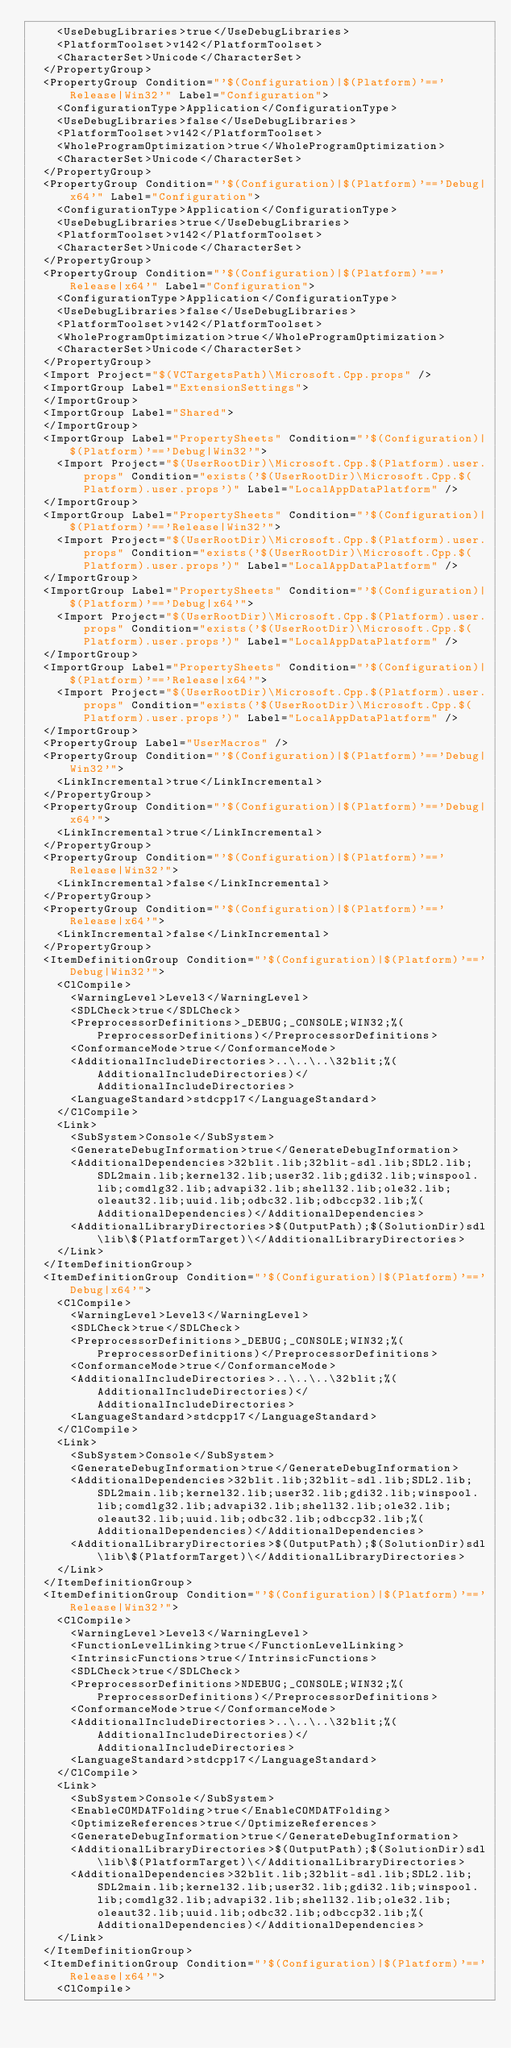<code> <loc_0><loc_0><loc_500><loc_500><_XML_>    <UseDebugLibraries>true</UseDebugLibraries>
    <PlatformToolset>v142</PlatformToolset>
    <CharacterSet>Unicode</CharacterSet>
  </PropertyGroup>
  <PropertyGroup Condition="'$(Configuration)|$(Platform)'=='Release|Win32'" Label="Configuration">
    <ConfigurationType>Application</ConfigurationType>
    <UseDebugLibraries>false</UseDebugLibraries>
    <PlatformToolset>v142</PlatformToolset>
    <WholeProgramOptimization>true</WholeProgramOptimization>
    <CharacterSet>Unicode</CharacterSet>
  </PropertyGroup>
  <PropertyGroup Condition="'$(Configuration)|$(Platform)'=='Debug|x64'" Label="Configuration">
    <ConfigurationType>Application</ConfigurationType>
    <UseDebugLibraries>true</UseDebugLibraries>
    <PlatformToolset>v142</PlatformToolset>
    <CharacterSet>Unicode</CharacterSet>
  </PropertyGroup>
  <PropertyGroup Condition="'$(Configuration)|$(Platform)'=='Release|x64'" Label="Configuration">
    <ConfigurationType>Application</ConfigurationType>
    <UseDebugLibraries>false</UseDebugLibraries>
    <PlatformToolset>v142</PlatformToolset>
    <WholeProgramOptimization>true</WholeProgramOptimization>
    <CharacterSet>Unicode</CharacterSet>
  </PropertyGroup>
  <Import Project="$(VCTargetsPath)\Microsoft.Cpp.props" />
  <ImportGroup Label="ExtensionSettings">
  </ImportGroup>
  <ImportGroup Label="Shared">
  </ImportGroup>
  <ImportGroup Label="PropertySheets" Condition="'$(Configuration)|$(Platform)'=='Debug|Win32'">
    <Import Project="$(UserRootDir)\Microsoft.Cpp.$(Platform).user.props" Condition="exists('$(UserRootDir)\Microsoft.Cpp.$(Platform).user.props')" Label="LocalAppDataPlatform" />
  </ImportGroup>
  <ImportGroup Label="PropertySheets" Condition="'$(Configuration)|$(Platform)'=='Release|Win32'">
    <Import Project="$(UserRootDir)\Microsoft.Cpp.$(Platform).user.props" Condition="exists('$(UserRootDir)\Microsoft.Cpp.$(Platform).user.props')" Label="LocalAppDataPlatform" />
  </ImportGroup>
  <ImportGroup Label="PropertySheets" Condition="'$(Configuration)|$(Platform)'=='Debug|x64'">
    <Import Project="$(UserRootDir)\Microsoft.Cpp.$(Platform).user.props" Condition="exists('$(UserRootDir)\Microsoft.Cpp.$(Platform).user.props')" Label="LocalAppDataPlatform" />
  </ImportGroup>
  <ImportGroup Label="PropertySheets" Condition="'$(Configuration)|$(Platform)'=='Release|x64'">
    <Import Project="$(UserRootDir)\Microsoft.Cpp.$(Platform).user.props" Condition="exists('$(UserRootDir)\Microsoft.Cpp.$(Platform).user.props')" Label="LocalAppDataPlatform" />
  </ImportGroup>
  <PropertyGroup Label="UserMacros" />
  <PropertyGroup Condition="'$(Configuration)|$(Platform)'=='Debug|Win32'">
    <LinkIncremental>true</LinkIncremental>
  </PropertyGroup>
  <PropertyGroup Condition="'$(Configuration)|$(Platform)'=='Debug|x64'">
    <LinkIncremental>true</LinkIncremental>
  </PropertyGroup>
  <PropertyGroup Condition="'$(Configuration)|$(Platform)'=='Release|Win32'">
    <LinkIncremental>false</LinkIncremental>
  </PropertyGroup>
  <PropertyGroup Condition="'$(Configuration)|$(Platform)'=='Release|x64'">
    <LinkIncremental>false</LinkIncremental>
  </PropertyGroup>
  <ItemDefinitionGroup Condition="'$(Configuration)|$(Platform)'=='Debug|Win32'">
    <ClCompile>
      <WarningLevel>Level3</WarningLevel>
      <SDLCheck>true</SDLCheck>
      <PreprocessorDefinitions>_DEBUG;_CONSOLE;WIN32;%(PreprocessorDefinitions)</PreprocessorDefinitions>
      <ConformanceMode>true</ConformanceMode>
      <AdditionalIncludeDirectories>..\..\..\32blit;%(AdditionalIncludeDirectories)</AdditionalIncludeDirectories>
      <LanguageStandard>stdcpp17</LanguageStandard>
    </ClCompile>
    <Link>
      <SubSystem>Console</SubSystem>
      <GenerateDebugInformation>true</GenerateDebugInformation>
      <AdditionalDependencies>32blit.lib;32blit-sdl.lib;SDL2.lib;SDL2main.lib;kernel32.lib;user32.lib;gdi32.lib;winspool.lib;comdlg32.lib;advapi32.lib;shell32.lib;ole32.lib;oleaut32.lib;uuid.lib;odbc32.lib;odbccp32.lib;%(AdditionalDependencies)</AdditionalDependencies>
      <AdditionalLibraryDirectories>$(OutputPath);$(SolutionDir)sdl\lib\$(PlatformTarget)\</AdditionalLibraryDirectories>
    </Link>
  </ItemDefinitionGroup>
  <ItemDefinitionGroup Condition="'$(Configuration)|$(Platform)'=='Debug|x64'">
    <ClCompile>
      <WarningLevel>Level3</WarningLevel>
      <SDLCheck>true</SDLCheck>
      <PreprocessorDefinitions>_DEBUG;_CONSOLE;WIN32;%(PreprocessorDefinitions)</PreprocessorDefinitions>
      <ConformanceMode>true</ConformanceMode>
      <AdditionalIncludeDirectories>..\..\..\32blit;%(AdditionalIncludeDirectories)</AdditionalIncludeDirectories>
      <LanguageStandard>stdcpp17</LanguageStandard>
    </ClCompile>
    <Link>
      <SubSystem>Console</SubSystem>
      <GenerateDebugInformation>true</GenerateDebugInformation>
      <AdditionalDependencies>32blit.lib;32blit-sdl.lib;SDL2.lib;SDL2main.lib;kernel32.lib;user32.lib;gdi32.lib;winspool.lib;comdlg32.lib;advapi32.lib;shell32.lib;ole32.lib;oleaut32.lib;uuid.lib;odbc32.lib;odbccp32.lib;%(AdditionalDependencies)</AdditionalDependencies>
      <AdditionalLibraryDirectories>$(OutputPath);$(SolutionDir)sdl\lib\$(PlatformTarget)\</AdditionalLibraryDirectories>
    </Link>
  </ItemDefinitionGroup>
  <ItemDefinitionGroup Condition="'$(Configuration)|$(Platform)'=='Release|Win32'">
    <ClCompile>
      <WarningLevel>Level3</WarningLevel>
      <FunctionLevelLinking>true</FunctionLevelLinking>
      <IntrinsicFunctions>true</IntrinsicFunctions>
      <SDLCheck>true</SDLCheck>
      <PreprocessorDefinitions>NDEBUG;_CONSOLE;WIN32;%(PreprocessorDefinitions)</PreprocessorDefinitions>
      <ConformanceMode>true</ConformanceMode>
      <AdditionalIncludeDirectories>..\..\..\32blit;%(AdditionalIncludeDirectories)</AdditionalIncludeDirectories>
      <LanguageStandard>stdcpp17</LanguageStandard>
    </ClCompile>
    <Link>
      <SubSystem>Console</SubSystem>
      <EnableCOMDATFolding>true</EnableCOMDATFolding>
      <OptimizeReferences>true</OptimizeReferences>
      <GenerateDebugInformation>true</GenerateDebugInformation>
      <AdditionalLibraryDirectories>$(OutputPath);$(SolutionDir)sdl\lib\$(PlatformTarget)\</AdditionalLibraryDirectories>
      <AdditionalDependencies>32blit.lib;32blit-sdl.lib;SDL2.lib;SDL2main.lib;kernel32.lib;user32.lib;gdi32.lib;winspool.lib;comdlg32.lib;advapi32.lib;shell32.lib;ole32.lib;oleaut32.lib;uuid.lib;odbc32.lib;odbccp32.lib;%(AdditionalDependencies)</AdditionalDependencies>
    </Link>
  </ItemDefinitionGroup>
  <ItemDefinitionGroup Condition="'$(Configuration)|$(Platform)'=='Release|x64'">
    <ClCompile></code> 